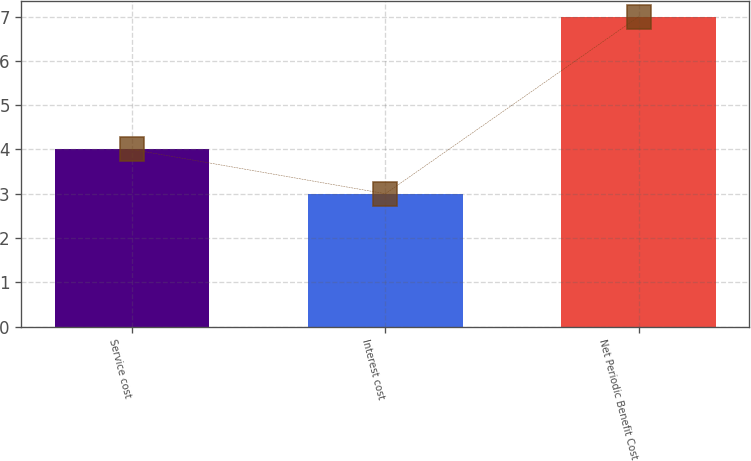Convert chart. <chart><loc_0><loc_0><loc_500><loc_500><bar_chart><fcel>Service cost<fcel>Interest cost<fcel>Net Periodic Benefit Cost<nl><fcel>4<fcel>3<fcel>7<nl></chart> 